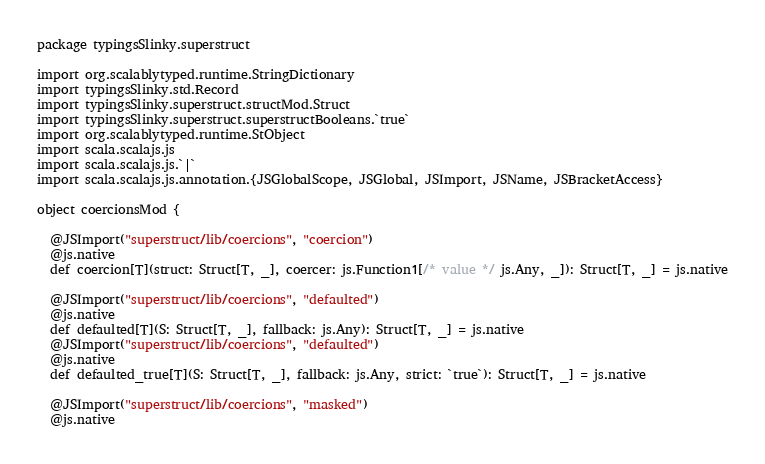Convert code to text. <code><loc_0><loc_0><loc_500><loc_500><_Scala_>package typingsSlinky.superstruct

import org.scalablytyped.runtime.StringDictionary
import typingsSlinky.std.Record
import typingsSlinky.superstruct.structMod.Struct
import typingsSlinky.superstruct.superstructBooleans.`true`
import org.scalablytyped.runtime.StObject
import scala.scalajs.js
import scala.scalajs.js.`|`
import scala.scalajs.js.annotation.{JSGlobalScope, JSGlobal, JSImport, JSName, JSBracketAccess}

object coercionsMod {
  
  @JSImport("superstruct/lib/coercions", "coercion")
  @js.native
  def coercion[T](struct: Struct[T, _], coercer: js.Function1[/* value */ js.Any, _]): Struct[T, _] = js.native
  
  @JSImport("superstruct/lib/coercions", "defaulted")
  @js.native
  def defaulted[T](S: Struct[T, _], fallback: js.Any): Struct[T, _] = js.native
  @JSImport("superstruct/lib/coercions", "defaulted")
  @js.native
  def defaulted_true[T](S: Struct[T, _], fallback: js.Any, strict: `true`): Struct[T, _] = js.native
  
  @JSImport("superstruct/lib/coercions", "masked")
  @js.native</code> 